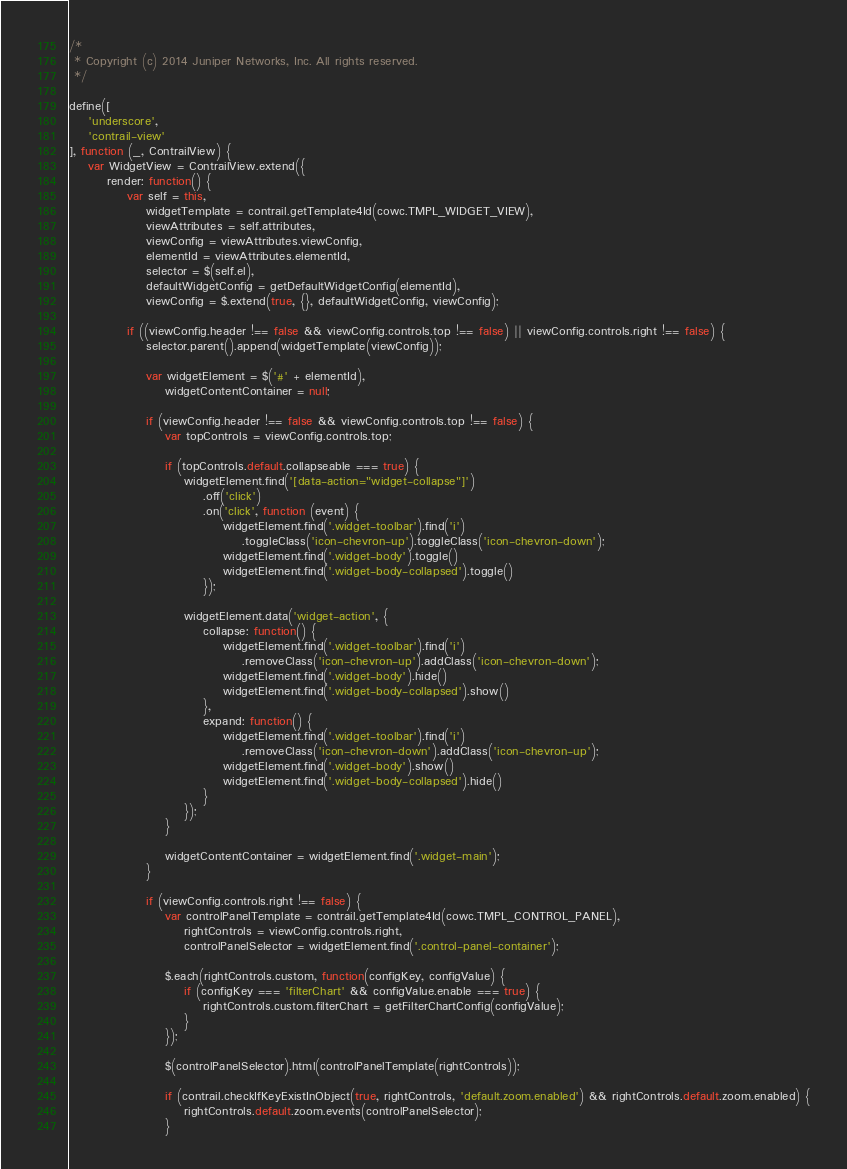<code> <loc_0><loc_0><loc_500><loc_500><_JavaScript_>/*
 * Copyright (c) 2014 Juniper Networks, Inc. All rights reserved.
 */

define([
    'underscore',
    'contrail-view'
], function (_, ContrailView) {
    var WidgetView = ContrailView.extend({
        render: function() {
            var self = this,
                widgetTemplate = contrail.getTemplate4Id(cowc.TMPL_WIDGET_VIEW),
                viewAttributes = self.attributes,
                viewConfig = viewAttributes.viewConfig,
                elementId = viewAttributes.elementId,
                selector = $(self.el),
                defaultWidgetConfig = getDefaultWidgetConfig(elementId),
                viewConfig = $.extend(true, {}, defaultWidgetConfig, viewConfig);

            if ((viewConfig.header !== false && viewConfig.controls.top !== false) || viewConfig.controls.right !== false) {
                selector.parent().append(widgetTemplate(viewConfig));

                var widgetElement = $('#' + elementId),
                    widgetContentContainer = null;

                if (viewConfig.header !== false && viewConfig.controls.top !== false) {
                    var topControls = viewConfig.controls.top;

                    if (topControls.default.collapseable === true) {
                        widgetElement.find('[data-action="widget-collapse"]')
                            .off('click')
                            .on('click', function (event) {
                                widgetElement.find('.widget-toolbar').find('i')
                                    .toggleClass('icon-chevron-up').toggleClass('icon-chevron-down');
                                widgetElement.find('.widget-body').toggle()
                                widgetElement.find('.widget-body-collapsed').toggle()
                            });

                        widgetElement.data('widget-action', {
                            collapse: function() {
                                widgetElement.find('.widget-toolbar').find('i')
                                    .removeClass('icon-chevron-up').addClass('icon-chevron-down');
                                widgetElement.find('.widget-body').hide()
                                widgetElement.find('.widget-body-collapsed').show()
                            },
                            expand: function() {
                                widgetElement.find('.widget-toolbar').find('i')
                                    .removeClass('icon-chevron-down').addClass('icon-chevron-up');
                                widgetElement.find('.widget-body').show()
                                widgetElement.find('.widget-body-collapsed').hide()
                            }
                        });
                    }

                    widgetContentContainer = widgetElement.find('.widget-main');
                }

                if (viewConfig.controls.right !== false) {
                    var controlPanelTemplate = contrail.getTemplate4Id(cowc.TMPL_CONTROL_PANEL),
                        rightControls = viewConfig.controls.right,
                        controlPanelSelector = widgetElement.find('.control-panel-container');

                    $.each(rightControls.custom, function(configKey, configValue) {
                        if (configKey === 'filterChart' && configValue.enable === true) {
                            rightControls.custom.filterChart = getFilterChartConfig(configValue);
                        }
                    });

                    $(controlPanelSelector).html(controlPanelTemplate(rightControls));

                    if (contrail.checkIfKeyExistInObject(true, rightControls, 'default.zoom.enabled') && rightControls.default.zoom.enabled) {
                        rightControls.default.zoom.events(controlPanelSelector);
                    }
</code> 